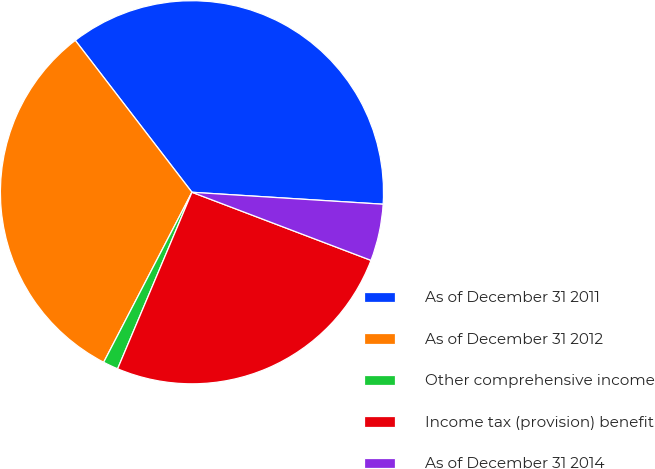Convert chart to OTSL. <chart><loc_0><loc_0><loc_500><loc_500><pie_chart><fcel>As of December 31 2011<fcel>As of December 31 2012<fcel>Other comprehensive income<fcel>Income tax (provision) benefit<fcel>As of December 31 2014<nl><fcel>36.42%<fcel>31.95%<fcel>1.28%<fcel>25.56%<fcel>4.79%<nl></chart> 